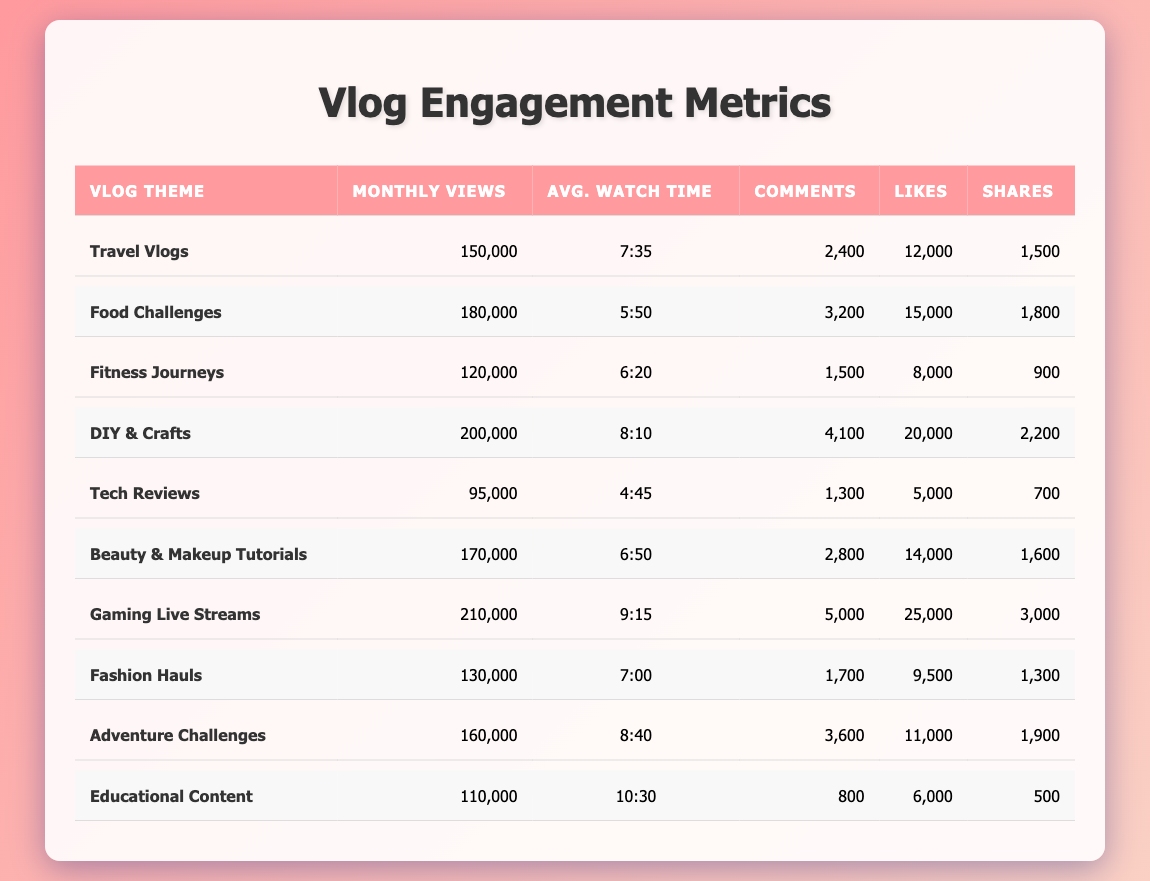What is the most viewed vlog theme? The vlog theme with the highest monthly views is "Gaming Live Streams," which has 210,000 views.
Answer: Gaming Live Streams Which vlog theme has the highest average watch time? The vlog theme with the highest average watch time is "Educational Content," with an average of 10 minutes and 30 seconds.
Answer: Educational Content How many more comments did "DIY & Crafts" receive compared to "Tech Reviews"? "DIY & Crafts" has 4,100 comments, while "Tech Reviews" has 1,300 comments. The difference is 4,100 - 1,300 = 2,800 comments.
Answer: 2800 What is the total number of likes for all vlog themes combined? Adding the likes from each theme: 12,000 + 15,000 + 8,000 + 20,000 + 5,000 + 14,000 + 25,000 + 9,500 + 11,000 + 6,000 =  125,500 total likes.
Answer: 125500 Is the average watch time for "Food Challenges" greater than that of "Fitness Journeys"? "Food Challenges" has an average watch time of 5 minutes and 50 seconds, while "Fitness Journeys" has 6 minutes and 20 seconds. Therefore, 5:50 is less than 6:20, so the statement is false.
Answer: No Which vlog theme received the most shares? The vlog theme with the most shares is "Gaming Live Streams," which received 3,000 shares.
Answer: Gaming Live Streams What is the average number of comments across all vlog themes? First, sum the comments: 2,400 + 3,200 + 1,500 + 4,100 + 1,300 + 2,800 + 5,000 + 1,700 + 3,600 + 800 = 26,600. Then, divide by the number of themes (10): 26,600 / 10 = 2,660.
Answer: 2660 How many vlog themes have monthly views greater than 150,000? The themes with views greater than 150,000 are "Food Challenges," "DIY & Crafts," "Gaming Live Streams," and "Adventure Challenges," totaling 4 themes.
Answer: 4 What is the difference between the most and least monthly views? The most views are from "Gaming Live Streams" with 210,000 and the least from "Tech Reviews" with 95,000. The difference is 210,000 - 95,000 = 115,000 views.
Answer: 115000 Which vlog theme has more likes: "Beauty & Makeup Tutorials" or "Adventure Challenges"? "Beauty & Makeup Tutorials" has 14,000 likes, while "Adventure Challenges" has 11,000. Thus, "Beauty & Makeup Tutorials" has more likes.
Answer: Beauty & Makeup Tutorials 